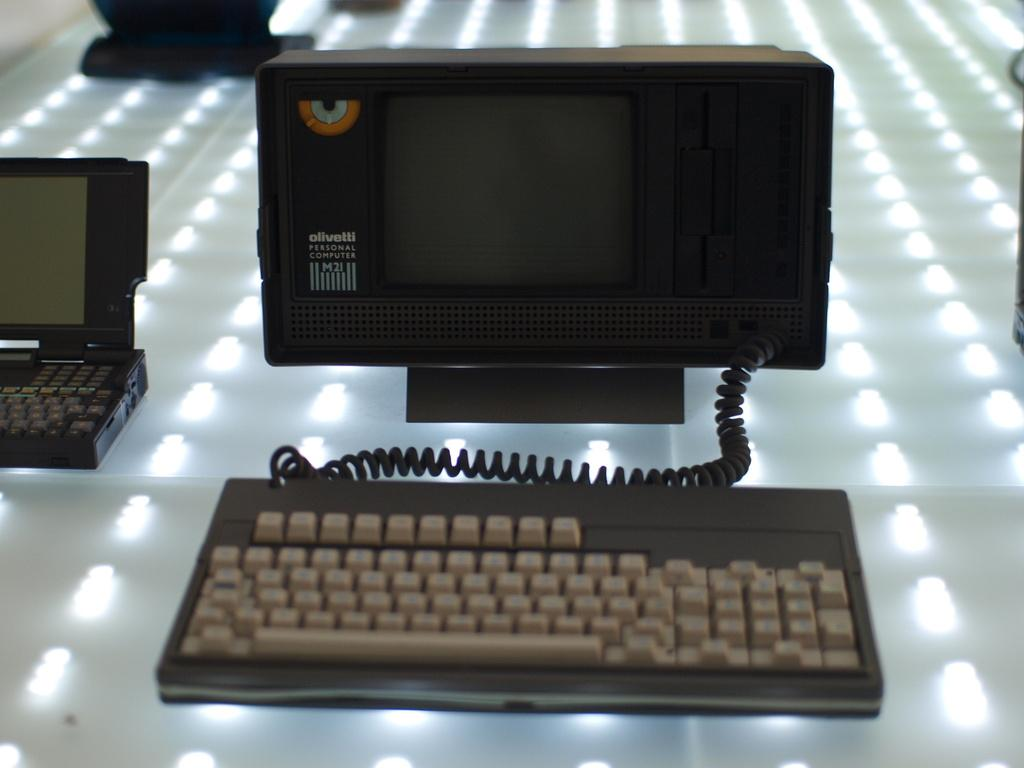<image>
Create a compact narrative representing the image presented. an olivetti personal computer M21 on a lighted counter 